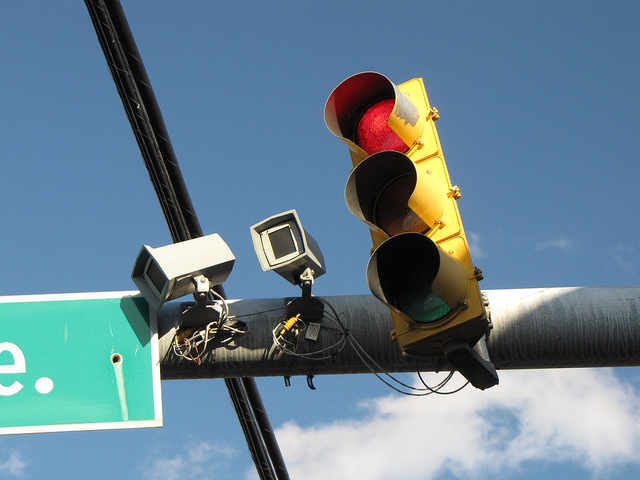How many red lights? There is one red light illuminated in the traffic signal. 